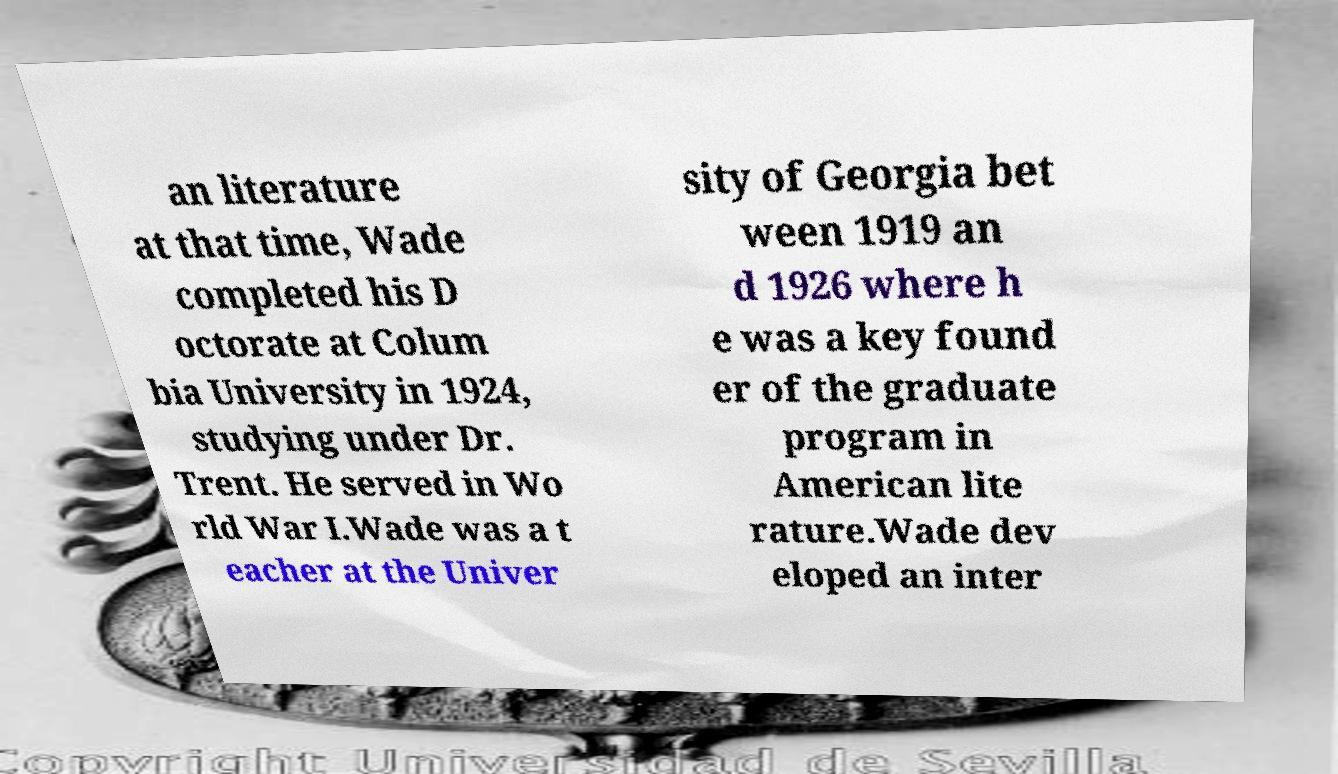Please read and relay the text visible in this image. What does it say? an literature at that time, Wade completed his D octorate at Colum bia University in 1924, studying under Dr. Trent. He served in Wo rld War I.Wade was a t eacher at the Univer sity of Georgia bet ween 1919 an d 1926 where h e was a key found er of the graduate program in American lite rature.Wade dev eloped an inter 